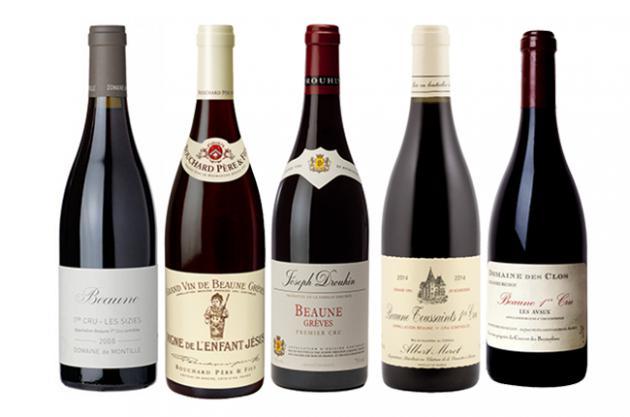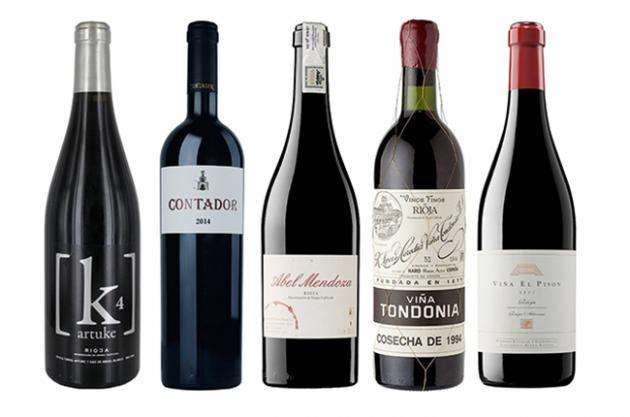The first image is the image on the left, the second image is the image on the right. Assess this claim about the two images: "There are no more than five wine bottles in the left image.". Correct or not? Answer yes or no. Yes. The first image is the image on the left, the second image is the image on the right. Examine the images to the left and right. Is the description "One of these images contains exactly four wine bottles." accurate? Answer yes or no. No. 